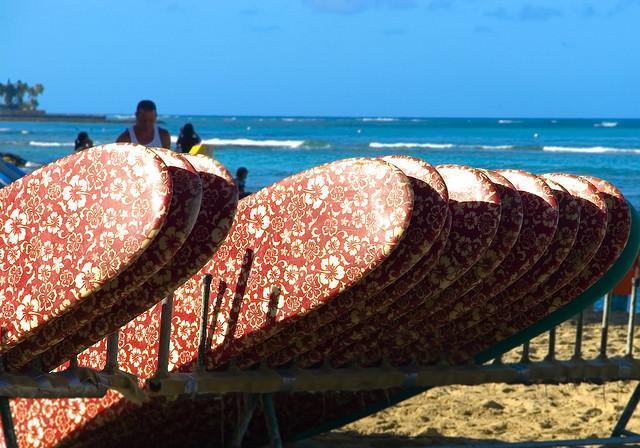How many surfboards are in the picture?
Give a very brief answer. 12. How many people can be seen?
Give a very brief answer. 4. How many surfboards can you see?
Give a very brief answer. 8. 